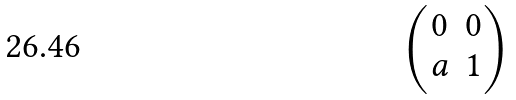<formula> <loc_0><loc_0><loc_500><loc_500>\begin{pmatrix} 0 & 0 \\ a & 1 \end{pmatrix}</formula> 